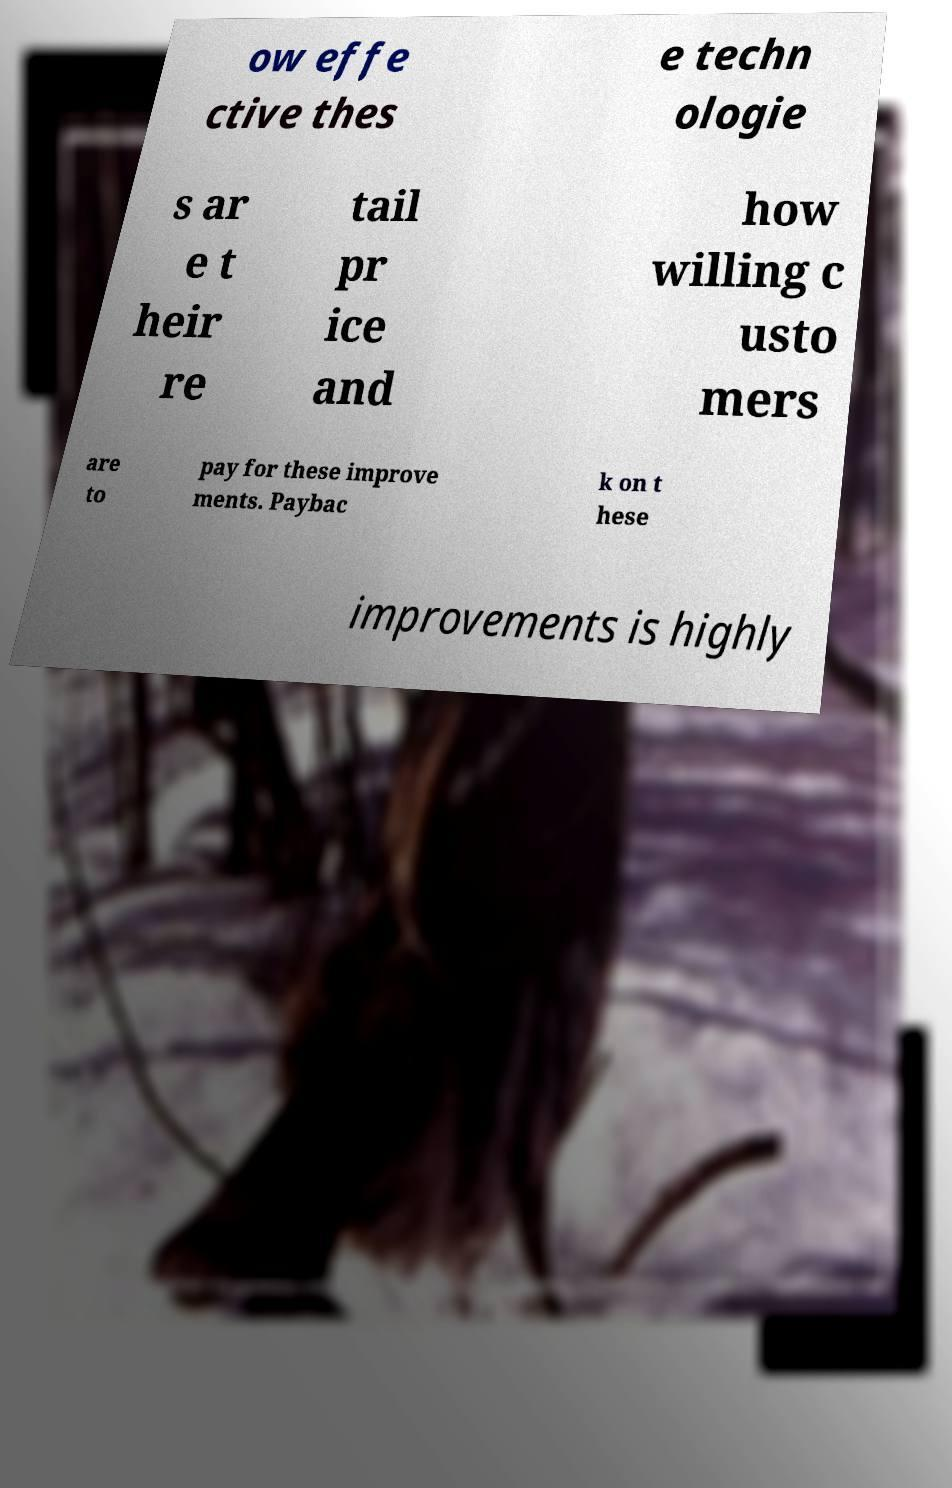What messages or text are displayed in this image? I need them in a readable, typed format. ow effe ctive thes e techn ologie s ar e t heir re tail pr ice and how willing c usto mers are to pay for these improve ments. Paybac k on t hese improvements is highly 